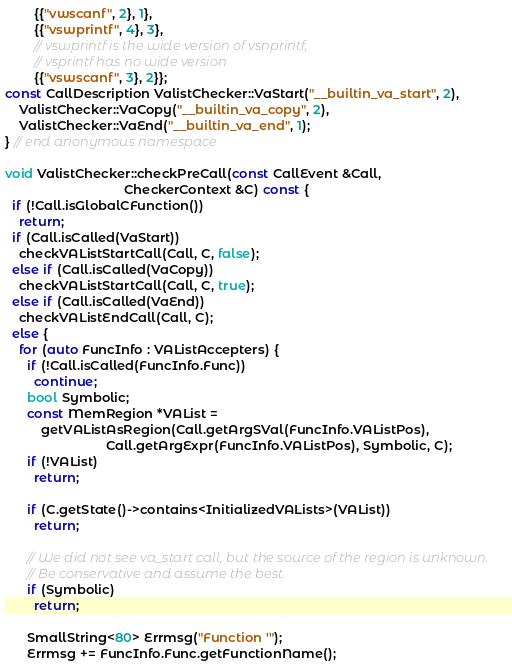Convert code to text. <code><loc_0><loc_0><loc_500><loc_500><_C++_>        {{"vwscanf", 2}, 1},
        {{"vswprintf", 4}, 3},
        // vswprintf is the wide version of vsnprintf,
        // vsprintf has no wide version
        {{"vswscanf", 3}, 2}};
const CallDescription ValistChecker::VaStart("__builtin_va_start", 2),
    ValistChecker::VaCopy("__builtin_va_copy", 2),
    ValistChecker::VaEnd("__builtin_va_end", 1);
} // end anonymous namespace

void ValistChecker::checkPreCall(const CallEvent &Call,
                                 CheckerContext &C) const {
  if (!Call.isGlobalCFunction())
    return;
  if (Call.isCalled(VaStart))
    checkVAListStartCall(Call, C, false);
  else if (Call.isCalled(VaCopy))
    checkVAListStartCall(Call, C, true);
  else if (Call.isCalled(VaEnd))
    checkVAListEndCall(Call, C);
  else {
    for (auto FuncInfo : VAListAccepters) {
      if (!Call.isCalled(FuncInfo.Func))
        continue;
      bool Symbolic;
      const MemRegion *VAList =
          getVAListAsRegion(Call.getArgSVal(FuncInfo.VAListPos),
                            Call.getArgExpr(FuncInfo.VAListPos), Symbolic, C);
      if (!VAList)
        return;

      if (C.getState()->contains<InitializedVALists>(VAList))
        return;

      // We did not see va_start call, but the source of the region is unknown.
      // Be conservative and assume the best.
      if (Symbolic)
        return;

      SmallString<80> Errmsg("Function '");
      Errmsg += FuncInfo.Func.getFunctionName();</code> 